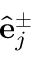Convert formula to latex. <formula><loc_0><loc_0><loc_500><loc_500>\hat { e } _ { j } ^ { \pm }</formula> 